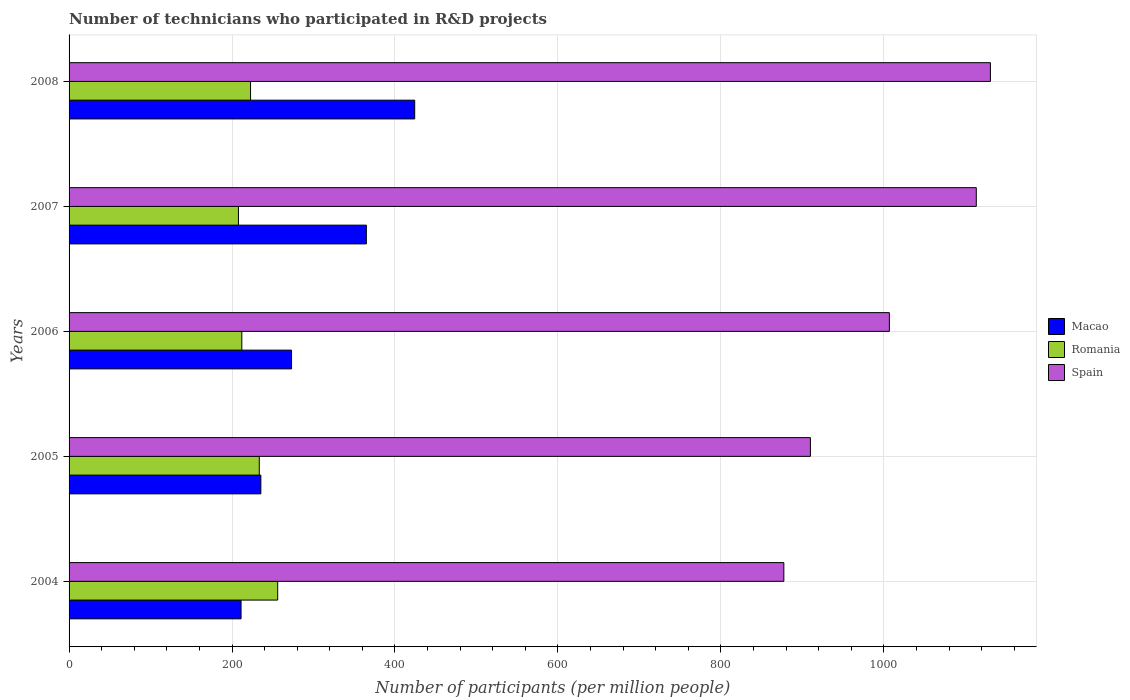How many different coloured bars are there?
Offer a very short reply. 3. Are the number of bars per tick equal to the number of legend labels?
Give a very brief answer. Yes. Are the number of bars on each tick of the Y-axis equal?
Offer a terse response. Yes. What is the label of the 5th group of bars from the top?
Give a very brief answer. 2004. In how many cases, is the number of bars for a given year not equal to the number of legend labels?
Offer a terse response. 0. What is the number of technicians who participated in R&D projects in Macao in 2006?
Ensure brevity in your answer.  273.07. Across all years, what is the maximum number of technicians who participated in R&D projects in Macao?
Offer a very short reply. 424.23. Across all years, what is the minimum number of technicians who participated in R&D projects in Macao?
Offer a terse response. 211.09. What is the total number of technicians who participated in R&D projects in Macao in the graph?
Give a very brief answer. 1508.67. What is the difference between the number of technicians who participated in R&D projects in Spain in 2004 and that in 2008?
Keep it short and to the point. -253.55. What is the difference between the number of technicians who participated in R&D projects in Romania in 2008 and the number of technicians who participated in R&D projects in Macao in 2007?
Offer a very short reply. -142.15. What is the average number of technicians who participated in R&D projects in Macao per year?
Your answer should be compact. 301.73. In the year 2007, what is the difference between the number of technicians who participated in R&D projects in Spain and number of technicians who participated in R&D projects in Romania?
Ensure brevity in your answer.  905.63. What is the ratio of the number of technicians who participated in R&D projects in Macao in 2007 to that in 2008?
Give a very brief answer. 0.86. Is the number of technicians who participated in R&D projects in Romania in 2006 less than that in 2007?
Offer a terse response. No. Is the difference between the number of technicians who participated in R&D projects in Spain in 2005 and 2006 greater than the difference between the number of technicians who participated in R&D projects in Romania in 2005 and 2006?
Your answer should be compact. No. What is the difference between the highest and the second highest number of technicians who participated in R&D projects in Romania?
Your answer should be compact. 22.58. What is the difference between the highest and the lowest number of technicians who participated in R&D projects in Macao?
Your answer should be very brief. 213.14. In how many years, is the number of technicians who participated in R&D projects in Spain greater than the average number of technicians who participated in R&D projects in Spain taken over all years?
Keep it short and to the point. 2. Is the sum of the number of technicians who participated in R&D projects in Spain in 2004 and 2007 greater than the maximum number of technicians who participated in R&D projects in Macao across all years?
Your answer should be very brief. Yes. What does the 3rd bar from the bottom in 2006 represents?
Provide a short and direct response. Spain. Is it the case that in every year, the sum of the number of technicians who participated in R&D projects in Romania and number of technicians who participated in R&D projects in Macao is greater than the number of technicians who participated in R&D projects in Spain?
Make the answer very short. No. How many bars are there?
Provide a short and direct response. 15. Are all the bars in the graph horizontal?
Your answer should be very brief. Yes. What is the difference between two consecutive major ticks on the X-axis?
Make the answer very short. 200. Does the graph contain any zero values?
Offer a very short reply. No. Does the graph contain grids?
Provide a succinct answer. Yes. What is the title of the graph?
Offer a very short reply. Number of technicians who participated in R&D projects. What is the label or title of the X-axis?
Your response must be concise. Number of participants (per million people). What is the label or title of the Y-axis?
Provide a short and direct response. Years. What is the Number of participants (per million people) of Macao in 2004?
Ensure brevity in your answer.  211.09. What is the Number of participants (per million people) in Romania in 2004?
Offer a terse response. 256.04. What is the Number of participants (per million people) of Spain in 2004?
Your response must be concise. 877.3. What is the Number of participants (per million people) of Macao in 2005?
Provide a short and direct response. 235.4. What is the Number of participants (per million people) in Romania in 2005?
Keep it short and to the point. 233.47. What is the Number of participants (per million people) of Spain in 2005?
Ensure brevity in your answer.  909.9. What is the Number of participants (per million people) in Macao in 2006?
Provide a short and direct response. 273.07. What is the Number of participants (per million people) of Romania in 2006?
Your answer should be compact. 212.02. What is the Number of participants (per million people) in Spain in 2006?
Keep it short and to the point. 1006.83. What is the Number of participants (per million people) of Macao in 2007?
Ensure brevity in your answer.  364.89. What is the Number of participants (per million people) in Romania in 2007?
Your answer should be very brief. 207.87. What is the Number of participants (per million people) of Spain in 2007?
Provide a short and direct response. 1113.5. What is the Number of participants (per million people) of Macao in 2008?
Provide a succinct answer. 424.23. What is the Number of participants (per million people) in Romania in 2008?
Give a very brief answer. 222.74. What is the Number of participants (per million people) in Spain in 2008?
Provide a succinct answer. 1130.85. Across all years, what is the maximum Number of participants (per million people) in Macao?
Offer a very short reply. 424.23. Across all years, what is the maximum Number of participants (per million people) in Romania?
Provide a succinct answer. 256.04. Across all years, what is the maximum Number of participants (per million people) in Spain?
Offer a very short reply. 1130.85. Across all years, what is the minimum Number of participants (per million people) of Macao?
Offer a terse response. 211.09. Across all years, what is the minimum Number of participants (per million people) in Romania?
Your answer should be very brief. 207.87. Across all years, what is the minimum Number of participants (per million people) of Spain?
Keep it short and to the point. 877.3. What is the total Number of participants (per million people) of Macao in the graph?
Ensure brevity in your answer.  1508.67. What is the total Number of participants (per million people) of Romania in the graph?
Your answer should be very brief. 1132.14. What is the total Number of participants (per million people) in Spain in the graph?
Provide a short and direct response. 5038.38. What is the difference between the Number of participants (per million people) in Macao in 2004 and that in 2005?
Your answer should be very brief. -24.31. What is the difference between the Number of participants (per million people) of Romania in 2004 and that in 2005?
Make the answer very short. 22.58. What is the difference between the Number of participants (per million people) in Spain in 2004 and that in 2005?
Your answer should be very brief. -32.6. What is the difference between the Number of participants (per million people) in Macao in 2004 and that in 2006?
Give a very brief answer. -61.98. What is the difference between the Number of participants (per million people) in Romania in 2004 and that in 2006?
Your response must be concise. 44.03. What is the difference between the Number of participants (per million people) in Spain in 2004 and that in 2006?
Your answer should be compact. -129.53. What is the difference between the Number of participants (per million people) in Macao in 2004 and that in 2007?
Give a very brief answer. -153.81. What is the difference between the Number of participants (per million people) in Romania in 2004 and that in 2007?
Your response must be concise. 48.18. What is the difference between the Number of participants (per million people) of Spain in 2004 and that in 2007?
Provide a short and direct response. -236.2. What is the difference between the Number of participants (per million people) in Macao in 2004 and that in 2008?
Your answer should be compact. -213.14. What is the difference between the Number of participants (per million people) of Romania in 2004 and that in 2008?
Your answer should be compact. 33.3. What is the difference between the Number of participants (per million people) of Spain in 2004 and that in 2008?
Give a very brief answer. -253.55. What is the difference between the Number of participants (per million people) of Macao in 2005 and that in 2006?
Make the answer very short. -37.68. What is the difference between the Number of participants (per million people) in Romania in 2005 and that in 2006?
Offer a very short reply. 21.45. What is the difference between the Number of participants (per million people) of Spain in 2005 and that in 2006?
Keep it short and to the point. -96.93. What is the difference between the Number of participants (per million people) in Macao in 2005 and that in 2007?
Keep it short and to the point. -129.5. What is the difference between the Number of participants (per million people) of Romania in 2005 and that in 2007?
Offer a very short reply. 25.6. What is the difference between the Number of participants (per million people) of Spain in 2005 and that in 2007?
Make the answer very short. -203.6. What is the difference between the Number of participants (per million people) in Macao in 2005 and that in 2008?
Give a very brief answer. -188.83. What is the difference between the Number of participants (per million people) of Romania in 2005 and that in 2008?
Your answer should be compact. 10.73. What is the difference between the Number of participants (per million people) of Spain in 2005 and that in 2008?
Make the answer very short. -220.95. What is the difference between the Number of participants (per million people) in Macao in 2006 and that in 2007?
Your answer should be compact. -91.82. What is the difference between the Number of participants (per million people) of Romania in 2006 and that in 2007?
Provide a short and direct response. 4.15. What is the difference between the Number of participants (per million people) of Spain in 2006 and that in 2007?
Your answer should be very brief. -106.67. What is the difference between the Number of participants (per million people) of Macao in 2006 and that in 2008?
Your answer should be very brief. -151.16. What is the difference between the Number of participants (per million people) in Romania in 2006 and that in 2008?
Ensure brevity in your answer.  -10.72. What is the difference between the Number of participants (per million people) in Spain in 2006 and that in 2008?
Offer a very short reply. -124.02. What is the difference between the Number of participants (per million people) of Macao in 2007 and that in 2008?
Give a very brief answer. -59.34. What is the difference between the Number of participants (per million people) of Romania in 2007 and that in 2008?
Offer a terse response. -14.87. What is the difference between the Number of participants (per million people) of Spain in 2007 and that in 2008?
Your answer should be compact. -17.35. What is the difference between the Number of participants (per million people) of Macao in 2004 and the Number of participants (per million people) of Romania in 2005?
Your answer should be compact. -22.38. What is the difference between the Number of participants (per million people) of Macao in 2004 and the Number of participants (per million people) of Spain in 2005?
Make the answer very short. -698.81. What is the difference between the Number of participants (per million people) in Romania in 2004 and the Number of participants (per million people) in Spain in 2005?
Make the answer very short. -653.86. What is the difference between the Number of participants (per million people) in Macao in 2004 and the Number of participants (per million people) in Romania in 2006?
Your answer should be very brief. -0.93. What is the difference between the Number of participants (per million people) in Macao in 2004 and the Number of participants (per million people) in Spain in 2006?
Provide a short and direct response. -795.74. What is the difference between the Number of participants (per million people) in Romania in 2004 and the Number of participants (per million people) in Spain in 2006?
Give a very brief answer. -750.79. What is the difference between the Number of participants (per million people) of Macao in 2004 and the Number of participants (per million people) of Romania in 2007?
Offer a terse response. 3.22. What is the difference between the Number of participants (per million people) in Macao in 2004 and the Number of participants (per million people) in Spain in 2007?
Offer a terse response. -902.41. What is the difference between the Number of participants (per million people) of Romania in 2004 and the Number of participants (per million people) of Spain in 2007?
Your answer should be very brief. -857.46. What is the difference between the Number of participants (per million people) of Macao in 2004 and the Number of participants (per million people) of Romania in 2008?
Ensure brevity in your answer.  -11.65. What is the difference between the Number of participants (per million people) of Macao in 2004 and the Number of participants (per million people) of Spain in 2008?
Make the answer very short. -919.76. What is the difference between the Number of participants (per million people) of Romania in 2004 and the Number of participants (per million people) of Spain in 2008?
Ensure brevity in your answer.  -874.8. What is the difference between the Number of participants (per million people) in Macao in 2005 and the Number of participants (per million people) in Romania in 2006?
Give a very brief answer. 23.38. What is the difference between the Number of participants (per million people) of Macao in 2005 and the Number of participants (per million people) of Spain in 2006?
Your response must be concise. -771.43. What is the difference between the Number of participants (per million people) of Romania in 2005 and the Number of participants (per million people) of Spain in 2006?
Offer a terse response. -773.36. What is the difference between the Number of participants (per million people) of Macao in 2005 and the Number of participants (per million people) of Romania in 2007?
Your answer should be very brief. 27.53. What is the difference between the Number of participants (per million people) of Macao in 2005 and the Number of participants (per million people) of Spain in 2007?
Offer a very short reply. -878.11. What is the difference between the Number of participants (per million people) of Romania in 2005 and the Number of participants (per million people) of Spain in 2007?
Your answer should be compact. -880.03. What is the difference between the Number of participants (per million people) of Macao in 2005 and the Number of participants (per million people) of Romania in 2008?
Provide a succinct answer. 12.66. What is the difference between the Number of participants (per million people) of Macao in 2005 and the Number of participants (per million people) of Spain in 2008?
Offer a terse response. -895.45. What is the difference between the Number of participants (per million people) of Romania in 2005 and the Number of participants (per million people) of Spain in 2008?
Provide a succinct answer. -897.38. What is the difference between the Number of participants (per million people) in Macao in 2006 and the Number of participants (per million people) in Romania in 2007?
Provide a succinct answer. 65.2. What is the difference between the Number of participants (per million people) of Macao in 2006 and the Number of participants (per million people) of Spain in 2007?
Ensure brevity in your answer.  -840.43. What is the difference between the Number of participants (per million people) of Romania in 2006 and the Number of participants (per million people) of Spain in 2007?
Provide a short and direct response. -901.49. What is the difference between the Number of participants (per million people) in Macao in 2006 and the Number of participants (per million people) in Romania in 2008?
Keep it short and to the point. 50.33. What is the difference between the Number of participants (per million people) in Macao in 2006 and the Number of participants (per million people) in Spain in 2008?
Offer a terse response. -857.78. What is the difference between the Number of participants (per million people) of Romania in 2006 and the Number of participants (per million people) of Spain in 2008?
Offer a terse response. -918.83. What is the difference between the Number of participants (per million people) in Macao in 2007 and the Number of participants (per million people) in Romania in 2008?
Ensure brevity in your answer.  142.15. What is the difference between the Number of participants (per million people) of Macao in 2007 and the Number of participants (per million people) of Spain in 2008?
Offer a terse response. -765.96. What is the difference between the Number of participants (per million people) of Romania in 2007 and the Number of participants (per million people) of Spain in 2008?
Ensure brevity in your answer.  -922.98. What is the average Number of participants (per million people) in Macao per year?
Offer a very short reply. 301.73. What is the average Number of participants (per million people) in Romania per year?
Your answer should be compact. 226.43. What is the average Number of participants (per million people) in Spain per year?
Make the answer very short. 1007.68. In the year 2004, what is the difference between the Number of participants (per million people) of Macao and Number of participants (per million people) of Romania?
Ensure brevity in your answer.  -44.96. In the year 2004, what is the difference between the Number of participants (per million people) of Macao and Number of participants (per million people) of Spain?
Offer a terse response. -666.21. In the year 2004, what is the difference between the Number of participants (per million people) of Romania and Number of participants (per million people) of Spain?
Your response must be concise. -621.26. In the year 2005, what is the difference between the Number of participants (per million people) of Macao and Number of participants (per million people) of Romania?
Offer a very short reply. 1.93. In the year 2005, what is the difference between the Number of participants (per million people) in Macao and Number of participants (per million people) in Spain?
Your answer should be very brief. -674.51. In the year 2005, what is the difference between the Number of participants (per million people) in Romania and Number of participants (per million people) in Spain?
Your answer should be very brief. -676.43. In the year 2006, what is the difference between the Number of participants (per million people) of Macao and Number of participants (per million people) of Romania?
Offer a very short reply. 61.06. In the year 2006, what is the difference between the Number of participants (per million people) in Macao and Number of participants (per million people) in Spain?
Offer a terse response. -733.76. In the year 2006, what is the difference between the Number of participants (per million people) of Romania and Number of participants (per million people) of Spain?
Provide a succinct answer. -794.81. In the year 2007, what is the difference between the Number of participants (per million people) in Macao and Number of participants (per million people) in Romania?
Your response must be concise. 157.02. In the year 2007, what is the difference between the Number of participants (per million people) in Macao and Number of participants (per million people) in Spain?
Offer a very short reply. -748.61. In the year 2007, what is the difference between the Number of participants (per million people) of Romania and Number of participants (per million people) of Spain?
Your answer should be compact. -905.63. In the year 2008, what is the difference between the Number of participants (per million people) of Macao and Number of participants (per million people) of Romania?
Your response must be concise. 201.49. In the year 2008, what is the difference between the Number of participants (per million people) in Macao and Number of participants (per million people) in Spain?
Give a very brief answer. -706.62. In the year 2008, what is the difference between the Number of participants (per million people) in Romania and Number of participants (per million people) in Spain?
Offer a very short reply. -908.11. What is the ratio of the Number of participants (per million people) in Macao in 2004 to that in 2005?
Offer a terse response. 0.9. What is the ratio of the Number of participants (per million people) of Romania in 2004 to that in 2005?
Your answer should be compact. 1.1. What is the ratio of the Number of participants (per million people) in Spain in 2004 to that in 2005?
Give a very brief answer. 0.96. What is the ratio of the Number of participants (per million people) of Macao in 2004 to that in 2006?
Your response must be concise. 0.77. What is the ratio of the Number of participants (per million people) in Romania in 2004 to that in 2006?
Your response must be concise. 1.21. What is the ratio of the Number of participants (per million people) in Spain in 2004 to that in 2006?
Your response must be concise. 0.87. What is the ratio of the Number of participants (per million people) in Macao in 2004 to that in 2007?
Offer a terse response. 0.58. What is the ratio of the Number of participants (per million people) of Romania in 2004 to that in 2007?
Your answer should be compact. 1.23. What is the ratio of the Number of participants (per million people) in Spain in 2004 to that in 2007?
Your answer should be very brief. 0.79. What is the ratio of the Number of participants (per million people) of Macao in 2004 to that in 2008?
Make the answer very short. 0.5. What is the ratio of the Number of participants (per million people) in Romania in 2004 to that in 2008?
Offer a very short reply. 1.15. What is the ratio of the Number of participants (per million people) of Spain in 2004 to that in 2008?
Make the answer very short. 0.78. What is the ratio of the Number of participants (per million people) of Macao in 2005 to that in 2006?
Offer a terse response. 0.86. What is the ratio of the Number of participants (per million people) in Romania in 2005 to that in 2006?
Provide a succinct answer. 1.1. What is the ratio of the Number of participants (per million people) of Spain in 2005 to that in 2006?
Ensure brevity in your answer.  0.9. What is the ratio of the Number of participants (per million people) of Macao in 2005 to that in 2007?
Keep it short and to the point. 0.65. What is the ratio of the Number of participants (per million people) in Romania in 2005 to that in 2007?
Keep it short and to the point. 1.12. What is the ratio of the Number of participants (per million people) in Spain in 2005 to that in 2007?
Your response must be concise. 0.82. What is the ratio of the Number of participants (per million people) of Macao in 2005 to that in 2008?
Ensure brevity in your answer.  0.55. What is the ratio of the Number of participants (per million people) of Romania in 2005 to that in 2008?
Your response must be concise. 1.05. What is the ratio of the Number of participants (per million people) of Spain in 2005 to that in 2008?
Your response must be concise. 0.8. What is the ratio of the Number of participants (per million people) of Macao in 2006 to that in 2007?
Offer a terse response. 0.75. What is the ratio of the Number of participants (per million people) of Romania in 2006 to that in 2007?
Offer a terse response. 1.02. What is the ratio of the Number of participants (per million people) of Spain in 2006 to that in 2007?
Make the answer very short. 0.9. What is the ratio of the Number of participants (per million people) in Macao in 2006 to that in 2008?
Make the answer very short. 0.64. What is the ratio of the Number of participants (per million people) in Romania in 2006 to that in 2008?
Make the answer very short. 0.95. What is the ratio of the Number of participants (per million people) in Spain in 2006 to that in 2008?
Make the answer very short. 0.89. What is the ratio of the Number of participants (per million people) in Macao in 2007 to that in 2008?
Ensure brevity in your answer.  0.86. What is the ratio of the Number of participants (per million people) in Romania in 2007 to that in 2008?
Ensure brevity in your answer.  0.93. What is the ratio of the Number of participants (per million people) of Spain in 2007 to that in 2008?
Make the answer very short. 0.98. What is the difference between the highest and the second highest Number of participants (per million people) of Macao?
Offer a terse response. 59.34. What is the difference between the highest and the second highest Number of participants (per million people) of Romania?
Keep it short and to the point. 22.58. What is the difference between the highest and the second highest Number of participants (per million people) in Spain?
Keep it short and to the point. 17.35. What is the difference between the highest and the lowest Number of participants (per million people) in Macao?
Your response must be concise. 213.14. What is the difference between the highest and the lowest Number of participants (per million people) in Romania?
Provide a succinct answer. 48.18. What is the difference between the highest and the lowest Number of participants (per million people) of Spain?
Your answer should be compact. 253.55. 